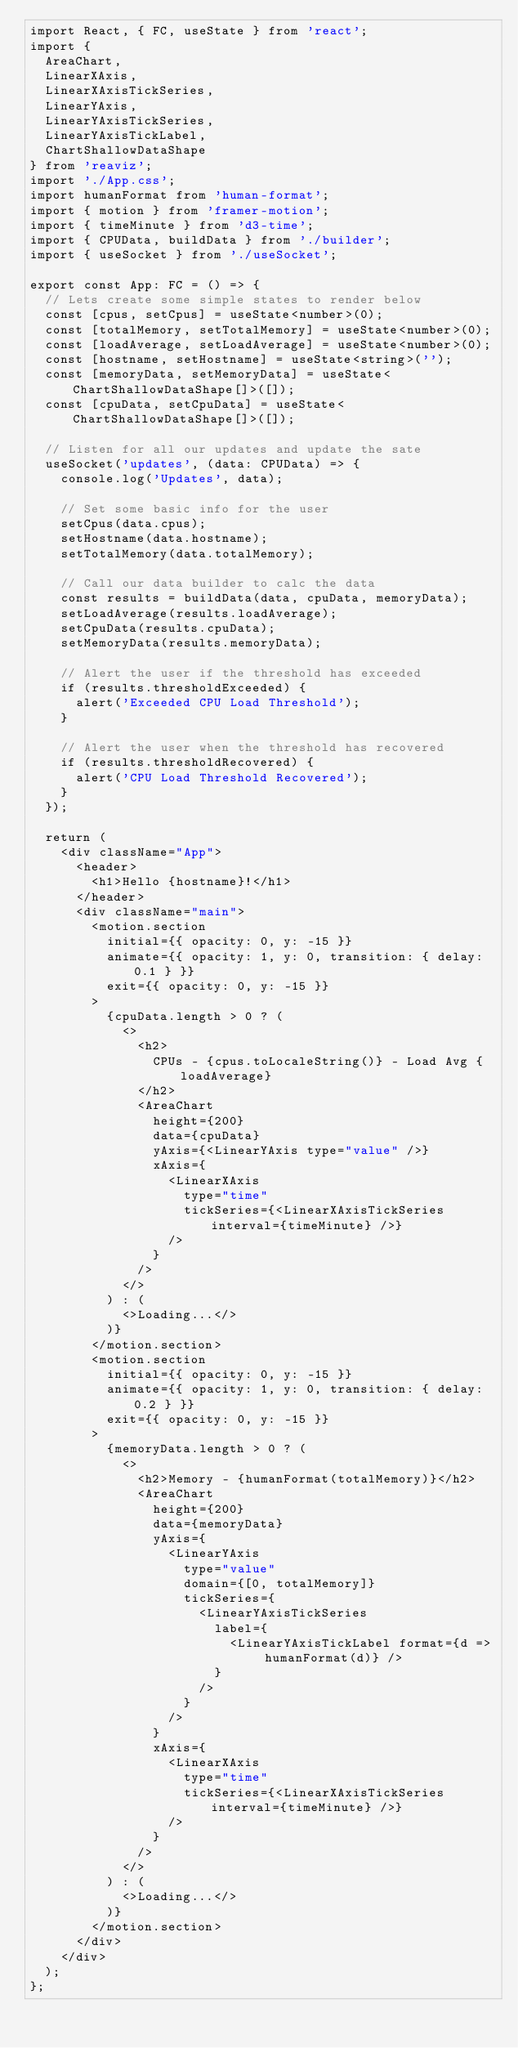<code> <loc_0><loc_0><loc_500><loc_500><_TypeScript_>import React, { FC, useState } from 'react';
import {
  AreaChart,
  LinearXAxis,
  LinearXAxisTickSeries,
  LinearYAxis,
  LinearYAxisTickSeries,
  LinearYAxisTickLabel,
  ChartShallowDataShape
} from 'reaviz';
import './App.css';
import humanFormat from 'human-format';
import { motion } from 'framer-motion';
import { timeMinute } from 'd3-time';
import { CPUData, buildData } from './builder';
import { useSocket } from './useSocket';

export const App: FC = () => {
  // Lets create some simple states to render below
  const [cpus, setCpus] = useState<number>(0);
  const [totalMemory, setTotalMemory] = useState<number>(0);
  const [loadAverage, setLoadAverage] = useState<number>(0);
  const [hostname, setHostname] = useState<string>('');
  const [memoryData, setMemoryData] = useState<ChartShallowDataShape[]>([]);
  const [cpuData, setCpuData] = useState<ChartShallowDataShape[]>([]);

  // Listen for all our updates and update the sate
  useSocket('updates', (data: CPUData) => {
    console.log('Updates', data);

    // Set some basic info for the user
    setCpus(data.cpus);
    setHostname(data.hostname);
    setTotalMemory(data.totalMemory);

    // Call our data builder to calc the data
    const results = buildData(data, cpuData, memoryData);
    setLoadAverage(results.loadAverage);
    setCpuData(results.cpuData);
    setMemoryData(results.memoryData);

    // Alert the user if the threshold has exceeded
    if (results.thresholdExceeded) {
      alert('Exceeded CPU Load Threshold');
    }

    // Alert the user when the threshold has recovered
    if (results.thresholdRecovered) {
      alert('CPU Load Threshold Recovered');
    }
  });

  return (
    <div className="App">
      <header>
        <h1>Hello {hostname}!</h1>
      </header>
      <div className="main">
        <motion.section
          initial={{ opacity: 0, y: -15 }}
          animate={{ opacity: 1, y: 0, transition: { delay: 0.1 } }}
          exit={{ opacity: 0, y: -15 }}
        >
          {cpuData.length > 0 ? (
            <>
              <h2>
                CPUs - {cpus.toLocaleString()} - Load Avg {loadAverage}
              </h2>
              <AreaChart
                height={200}
                data={cpuData}
                yAxis={<LinearYAxis type="value" />}
                xAxis={
                  <LinearXAxis
                    type="time"
                    tickSeries={<LinearXAxisTickSeries interval={timeMinute} />}
                  />
                }
              />
            </>
          ) : (
            <>Loading...</>
          )}
        </motion.section>
        <motion.section
          initial={{ opacity: 0, y: -15 }}
          animate={{ opacity: 1, y: 0, transition: { delay: 0.2 } }}
          exit={{ opacity: 0, y: -15 }}
        >
          {memoryData.length > 0 ? (
            <>
              <h2>Memory - {humanFormat(totalMemory)}</h2>
              <AreaChart
                height={200}
                data={memoryData}
                yAxis={
                  <LinearYAxis
                    type="value"
                    domain={[0, totalMemory]}
                    tickSeries={
                      <LinearYAxisTickSeries
                        label={
                          <LinearYAxisTickLabel format={d => humanFormat(d)} />
                        }
                      />
                    }
                  />
                }
                xAxis={
                  <LinearXAxis
                    type="time"
                    tickSeries={<LinearXAxisTickSeries interval={timeMinute} />}
                  />
                }
              />
            </>
          ) : (
            <>Loading...</>
          )}
        </motion.section>
      </div>
    </div>
  );
};
</code> 